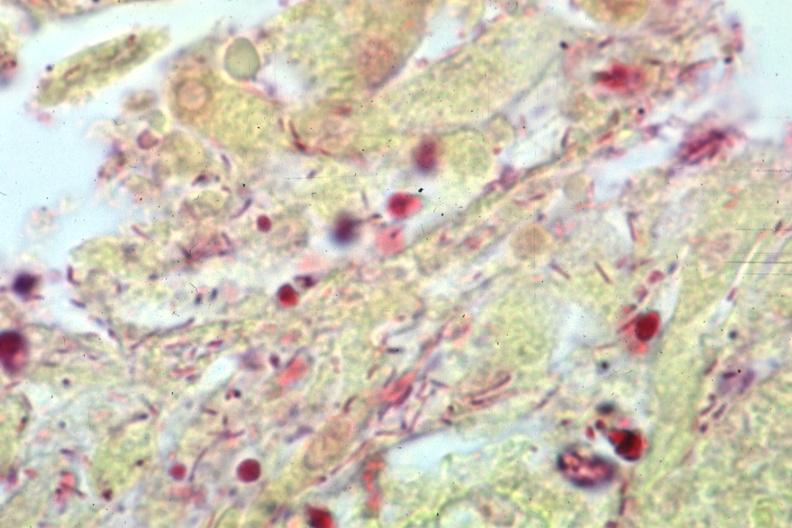does gangrene toe in infant stain gram negative bacteria?
Answer the question using a single word or phrase. No 